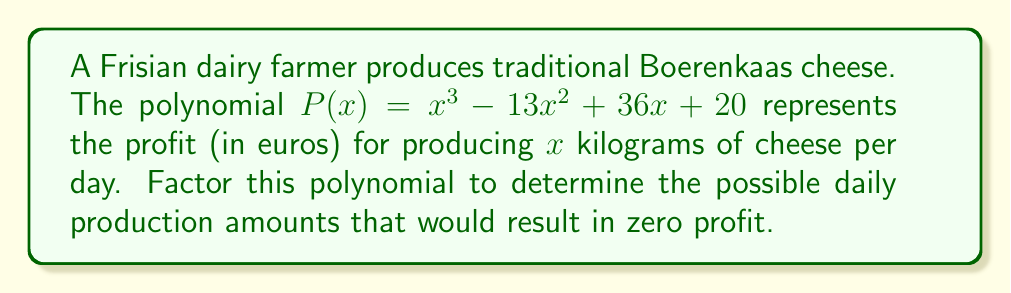Provide a solution to this math problem. To factor this polynomial, we'll follow these steps:

1) First, let's check if there's a common factor. In this case, there isn't.

2) Next, we'll use the rational root theorem to find potential roots. The factors of the constant term (20) are: ±1, ±2, ±4, ±5, ±10, ±20.

3) We'll use synthetic division to test these potential roots:

   $P(-1) = -1 - 13 - 36 + 20 = -30 \neq 0$
   $P(1) = 1 - 13 + 36 + 20 = 44 \neq 0$
   $P(2) = 8 - 52 + 72 + 20 = 48 \neq 0$
   $P(-2) = -8 - 52 - 72 + 20 = -112 \neq 0$
   $P(4) = 64 - 208 + 144 + 20 = 20 \neq 0$
   $P(-4) = -64 - 208 - 144 + 20 = -396 \neq 0$
   $P(5) = 125 - 325 + 180 + 20 = 0$

4) We found that 5 is a root. Let's use synthetic division to factor out $(x-5)$:

   $$
   \begin{array}{r}
   1 \quad -13 \quad 36 \quad 20 \\
   5 \quad -40 \quad -20 \\
   \hline
   1 \quad -8 \quad -4
   \end{array}
   $$

5) So, $P(x) = (x-5)(x^2 - 8x - 4)$

6) Now we need to factor $x^2 - 8x - 4$. We can do this by finding two numbers that multiply to give -4 and add to give -8. These numbers are -10 and 2.

7) Therefore, $x^2 - 8x - 4 = (x-10)(x+2)$

8) Our final factorization is:

   $P(x) = (x-5)(x-10)(x+2)$
Answer: $P(x) = (x-5)(x-10)(x+2)$

The possible daily production amounts that would result in zero profit are 5 kg, 10 kg, and -2 kg. However, since negative production doesn't make sense in this context, only 5 kg and 10 kg are realistic solutions. 